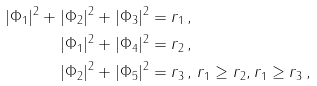<formula> <loc_0><loc_0><loc_500><loc_500>| \Phi _ { 1 } | ^ { 2 } + | \Phi _ { 2 } | ^ { 2 } + | \Phi _ { 3 } | ^ { 2 } & = r _ { 1 } \, , \\ | \Phi _ { 1 } | ^ { 2 } + | \Phi _ { 4 } | ^ { 2 } & = r _ { 2 } \, , \\ | \Phi _ { 2 } | ^ { 2 } + | \Phi _ { 5 } | ^ { 2 } & = r _ { 3 } \, , \, r _ { 1 } \geq r _ { 2 } , r _ { 1 } \geq r _ { 3 } \, ,</formula> 